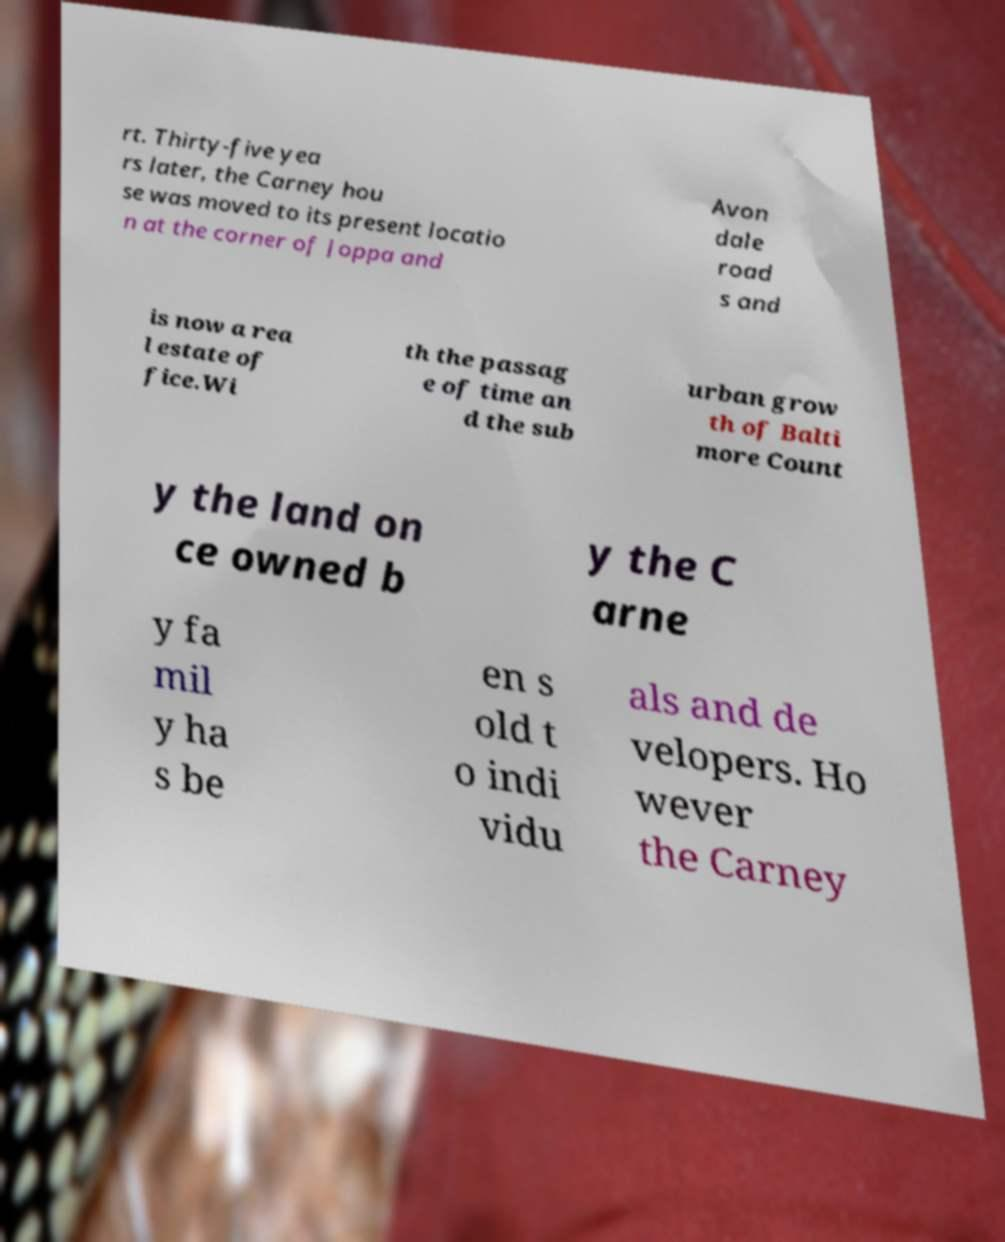Can you accurately transcribe the text from the provided image for me? rt. Thirty-five yea rs later, the Carney hou se was moved to its present locatio n at the corner of Joppa and Avon dale road s and is now a rea l estate of fice.Wi th the passag e of time an d the sub urban grow th of Balti more Count y the land on ce owned b y the C arne y fa mil y ha s be en s old t o indi vidu als and de velopers. Ho wever the Carney 